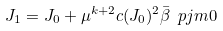<formula> <loc_0><loc_0><loc_500><loc_500>J _ { 1 } = J _ { 0 } + \mu ^ { k + 2 } c ( J _ { 0 } ) ^ { 2 } \bar { \beta } \ p j m 0</formula> 